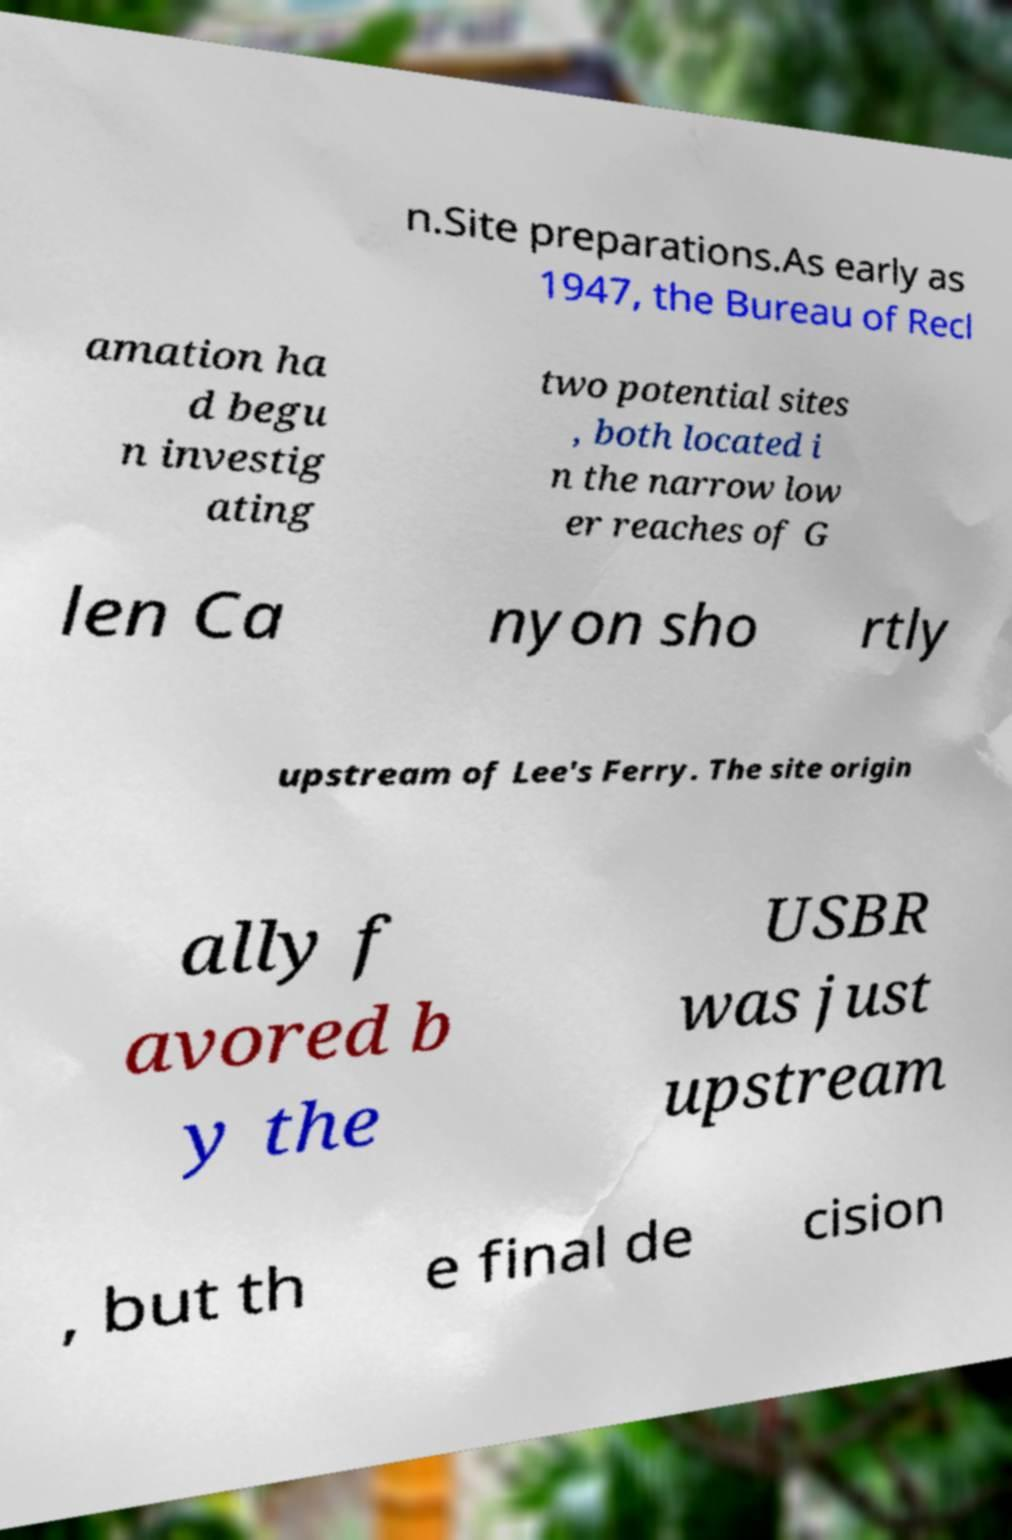What messages or text are displayed in this image? I need them in a readable, typed format. n.Site preparations.As early as 1947, the Bureau of Recl amation ha d begu n investig ating two potential sites , both located i n the narrow low er reaches of G len Ca nyon sho rtly upstream of Lee's Ferry. The site origin ally f avored b y the USBR was just upstream , but th e final de cision 